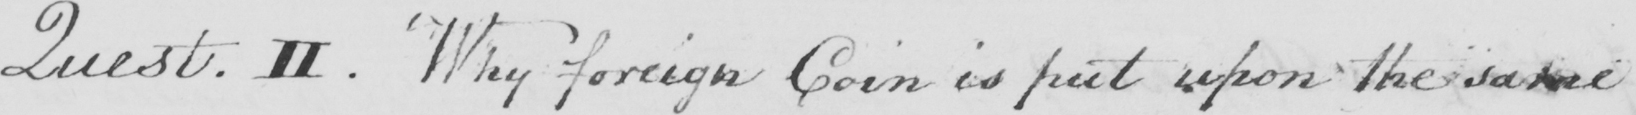What is written in this line of handwriting? Quest . II  . Why foreign Coin is put upon the same 